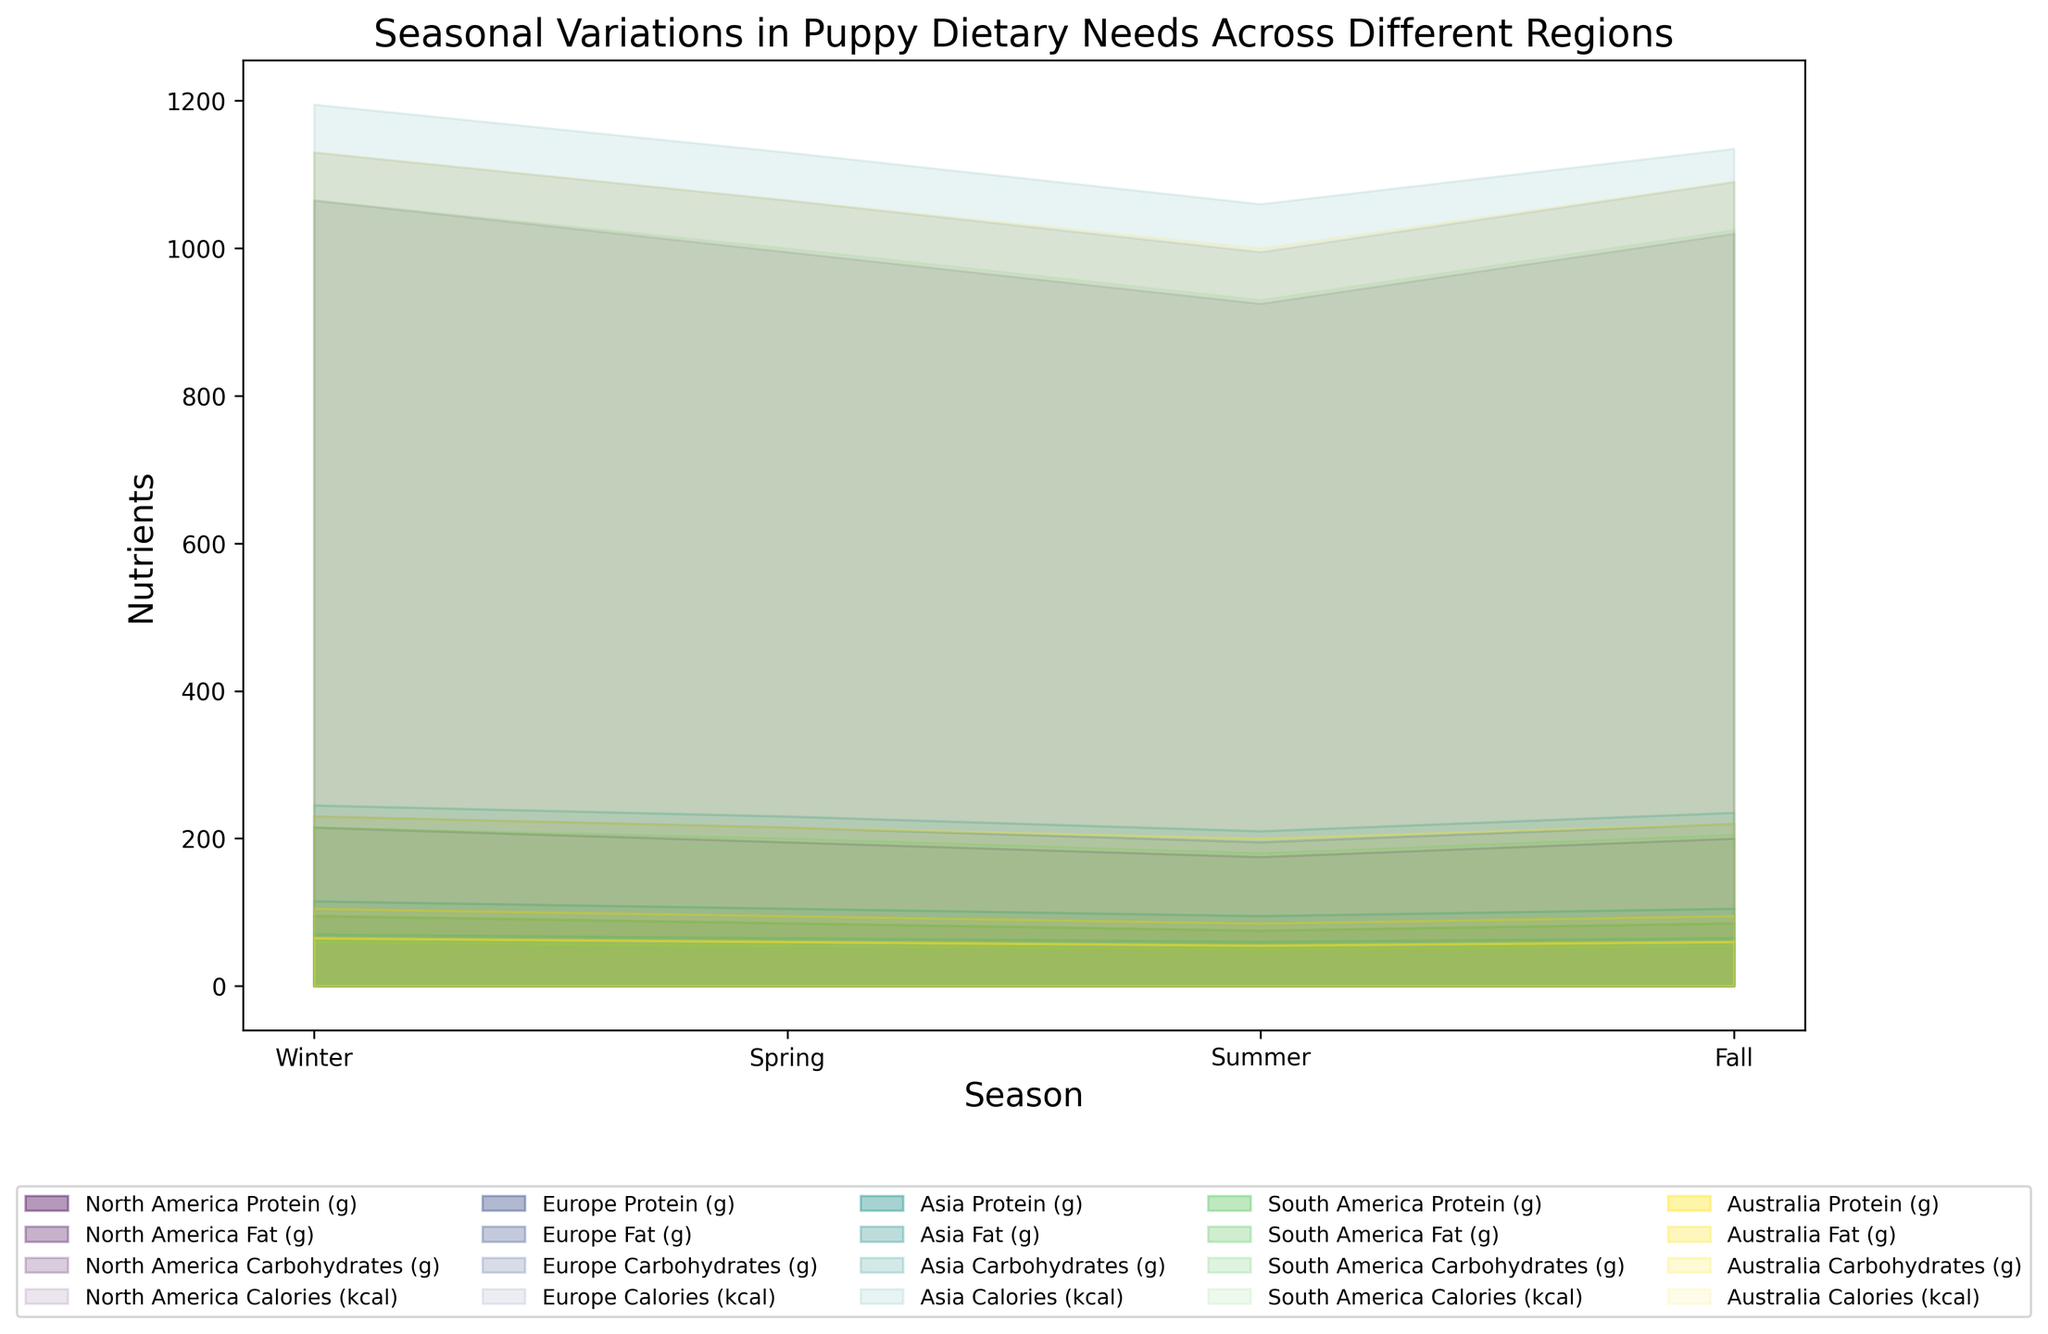Which region shows the highest protein intake during the Winter season? According to the area chart, the region with the highest protein intake in Winter is Asia. The visual shows a larger area filled for protein in Asia during Winter compared to other regions.
Answer: Asia Which season in North America has the lowest calorie requirement? By looking at the stacked areas for each season in North America, Summer shows the smallest total area, indicating the lowest calorie requirements.
Answer: Summer What is the total intake of nutrients (Protein, Fat, Carbohydrates) in Europe during Fall? To calculate the total intake for Europe in Fall: Protein (60g) + Fat (35g) + Carbohydrates (125g) = 220g.
Answer: 220g Which region has the smallest variation in calorie needs across different seasons? By analyzing the height differences of the calorie section across seasons for each region, South America appears to have the smallest variation in calorie needs, as the areas are visually more consistent across seasons.
Answer: South America In which region does the protein requirement decrease continuously from Winter to Summer? By following the protein areas from Winter to Summer for each region, North America shows a continuous decrease in protein requirement.
Answer: North America Comparing Winter seasons, which region has the highest fat intake? By examining the height of the fat sections during Winter for each region, Asia has the highest fat intake.
Answer: Asia During which season is the carbohydrate intake maximum in Australia? Analyzing the carbohydrate sections for each season in Australia, the highest intake occurs in Fall.
Answer: Fall 